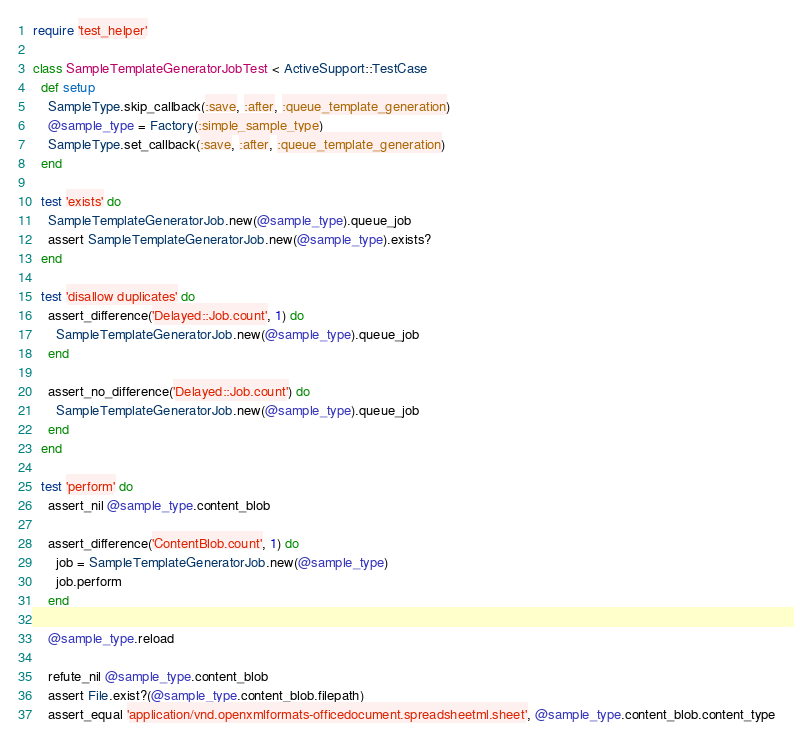<code> <loc_0><loc_0><loc_500><loc_500><_Ruby_>require 'test_helper'

class SampleTemplateGeneratorJobTest < ActiveSupport::TestCase
  def setup
    SampleType.skip_callback(:save, :after, :queue_template_generation)
    @sample_type = Factory(:simple_sample_type)
    SampleType.set_callback(:save, :after, :queue_template_generation)
  end

  test 'exists' do
    SampleTemplateGeneratorJob.new(@sample_type).queue_job
    assert SampleTemplateGeneratorJob.new(@sample_type).exists?
  end

  test 'disallow duplicates' do
    assert_difference('Delayed::Job.count', 1) do
      SampleTemplateGeneratorJob.new(@sample_type).queue_job
    end

    assert_no_difference('Delayed::Job.count') do
      SampleTemplateGeneratorJob.new(@sample_type).queue_job
    end
  end

  test 'perform' do
    assert_nil @sample_type.content_blob

    assert_difference('ContentBlob.count', 1) do
      job = SampleTemplateGeneratorJob.new(@sample_type)
      job.perform
    end

    @sample_type.reload

    refute_nil @sample_type.content_blob
    assert File.exist?(@sample_type.content_blob.filepath)
    assert_equal 'application/vnd.openxmlformats-officedocument.spreadsheetml.sheet', @sample_type.content_blob.content_type</code> 